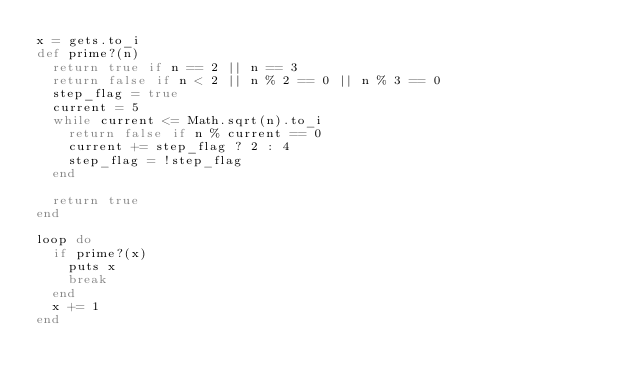Convert code to text. <code><loc_0><loc_0><loc_500><loc_500><_Ruby_>x = gets.to_i
def prime?(n)
  return true if n == 2 || n == 3
  return false if n < 2 || n % 2 == 0 || n % 3 == 0
  step_flag = true
  current = 5
  while current <= Math.sqrt(n).to_i
    return false if n % current == 0
    current += step_flag ? 2 : 4
    step_flag = !step_flag
  end

  return true
end

loop do
  if prime?(x)
    puts x
    break
  end
  x += 1
end</code> 